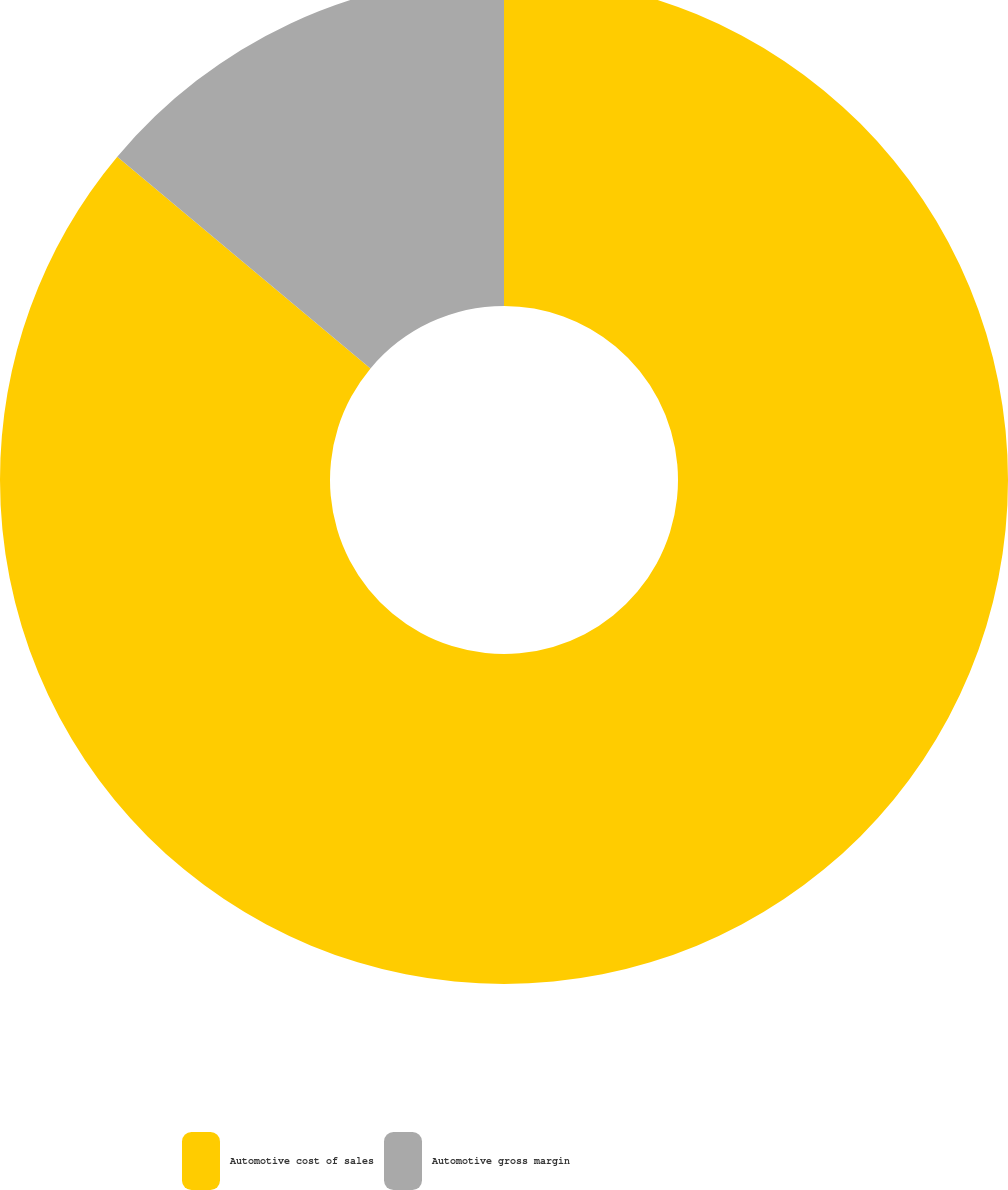Convert chart to OTSL. <chart><loc_0><loc_0><loc_500><loc_500><pie_chart><fcel>Automotive cost of sales<fcel>Automotive gross margin<nl><fcel>86.08%<fcel>13.92%<nl></chart> 